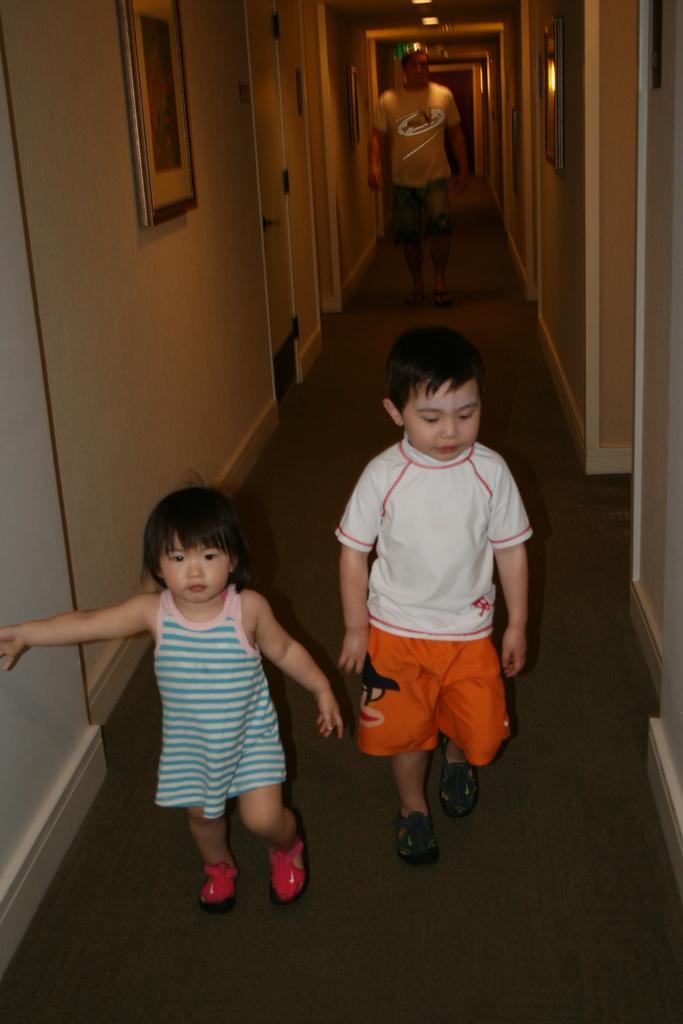Can you describe this image briefly? In this image I can see a man and two children are walking. On the left side of the image I can see a door and a frame on the wall. In the background I can see few more frames on the walls and few lights. 